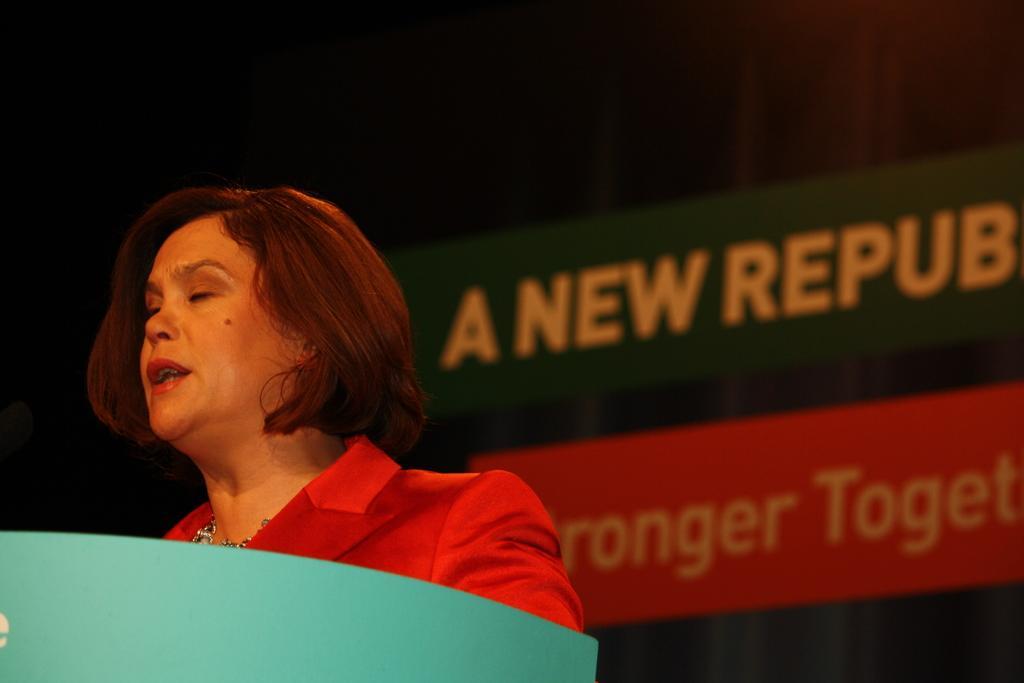Describe this image in one or two sentences. Here in this picture we can see an woman in red colored dress standing over a place and in front of her we can see a speech desk present and we can see she is speaking something, behind her we can see a banner present over there. 